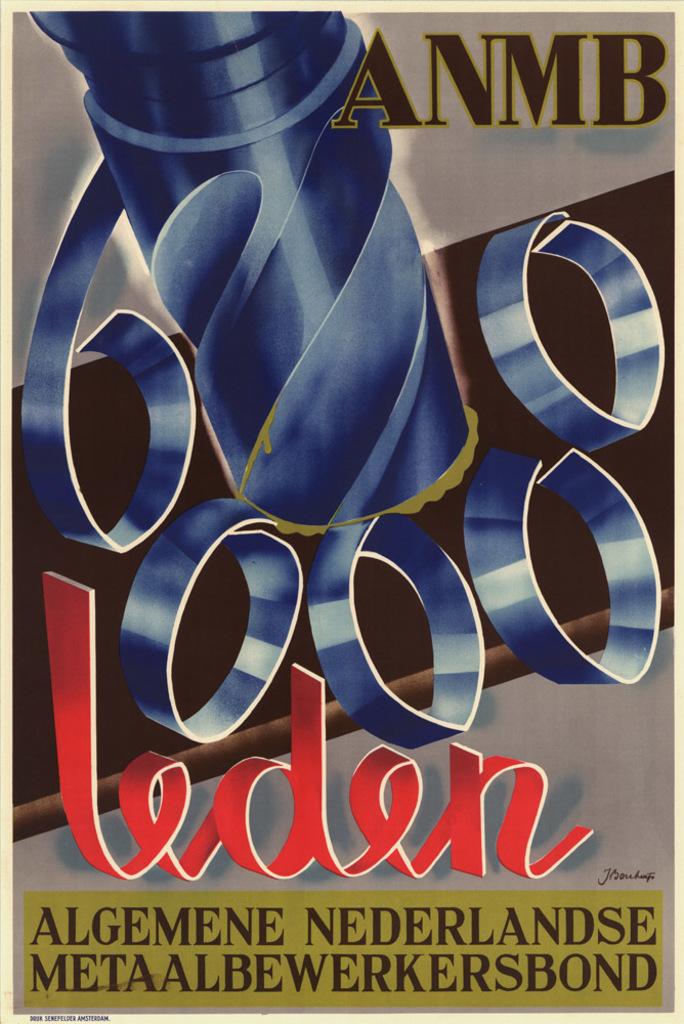What four letters are shown on the top of the picture?
Make the answer very short. Anmb. 